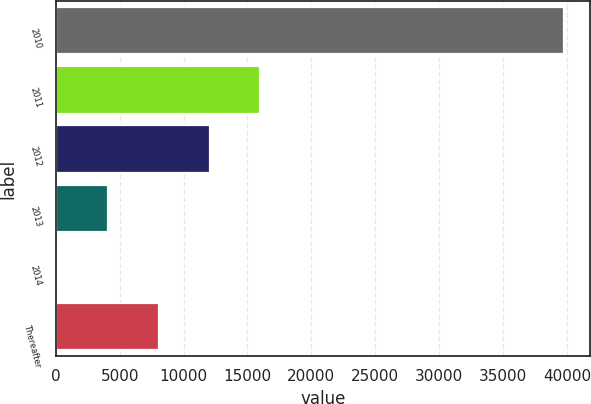Convert chart to OTSL. <chart><loc_0><loc_0><loc_500><loc_500><bar_chart><fcel>2010<fcel>2011<fcel>2012<fcel>2013<fcel>2014<fcel>Thereafter<nl><fcel>39801<fcel>16003.8<fcel>12037.6<fcel>4105.2<fcel>139<fcel>8071.4<nl></chart> 